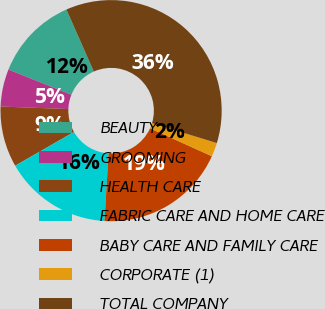Convert chart to OTSL. <chart><loc_0><loc_0><loc_500><loc_500><pie_chart><fcel>BEAUTY<fcel>GROOMING<fcel>HEALTH CARE<fcel>FABRIC CARE AND HOME CARE<fcel>BABY CARE AND FAMILY CARE<fcel>CORPORATE (1)<fcel>TOTAL COMPANY<nl><fcel>12.32%<fcel>5.46%<fcel>8.89%<fcel>15.76%<fcel>19.19%<fcel>2.03%<fcel>36.35%<nl></chart> 